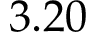Convert formula to latex. <formula><loc_0><loc_0><loc_500><loc_500>3 . 2 0</formula> 